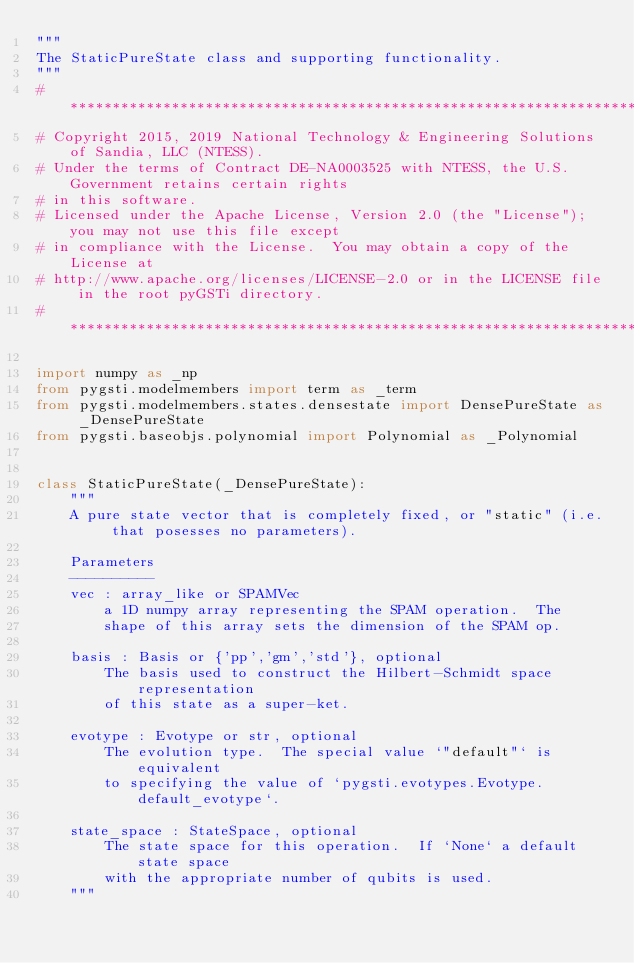Convert code to text. <code><loc_0><loc_0><loc_500><loc_500><_Python_>"""
The StaticPureState class and supporting functionality.
"""
#***************************************************************************************************
# Copyright 2015, 2019 National Technology & Engineering Solutions of Sandia, LLC (NTESS).
# Under the terms of Contract DE-NA0003525 with NTESS, the U.S. Government retains certain rights
# in this software.
# Licensed under the Apache License, Version 2.0 (the "License"); you may not use this file except
# in compliance with the License.  You may obtain a copy of the License at
# http://www.apache.org/licenses/LICENSE-2.0 or in the LICENSE file in the root pyGSTi directory.
#***************************************************************************************************

import numpy as _np
from pygsti.modelmembers import term as _term
from pygsti.modelmembers.states.densestate import DensePureState as _DensePureState
from pygsti.baseobjs.polynomial import Polynomial as _Polynomial


class StaticPureState(_DensePureState):
    """
    A pure state vector that is completely fixed, or "static" (i.e. that posesses no parameters).

    Parameters
    ----------
    vec : array_like or SPAMVec
        a 1D numpy array representing the SPAM operation.  The
        shape of this array sets the dimension of the SPAM op.

    basis : Basis or {'pp','gm','std'}, optional
        The basis used to construct the Hilbert-Schmidt space representation
        of this state as a super-ket.

    evotype : Evotype or str, optional
        The evolution type.  The special value `"default"` is equivalent
        to specifying the value of `pygsti.evotypes.Evotype.default_evotype`.

    state_space : StateSpace, optional
        The state space for this operation.  If `None` a default state space
        with the appropriate number of qubits is used.
    """
</code> 